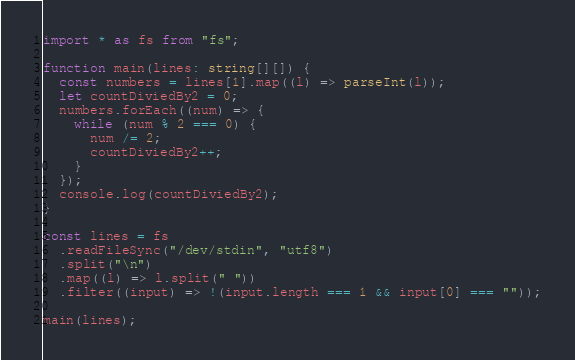Convert code to text. <code><loc_0><loc_0><loc_500><loc_500><_TypeScript_>import * as fs from "fs";

function main(lines: string[][]) {
  const numbers = lines[1].map((l) => parseInt(l));
  let countDiviedBy2 = 0;
  numbers.forEach((num) => {
    while (num % 2 === 0) {
      num /= 2;
      countDiviedBy2++;
    }
  });
  console.log(countDiviedBy2);
}

const lines = fs
  .readFileSync("/dev/stdin", "utf8")
  .split("\n")
  .map((l) => l.split(" "))
  .filter((input) => !(input.length === 1 && input[0] === ""));

main(lines);
</code> 